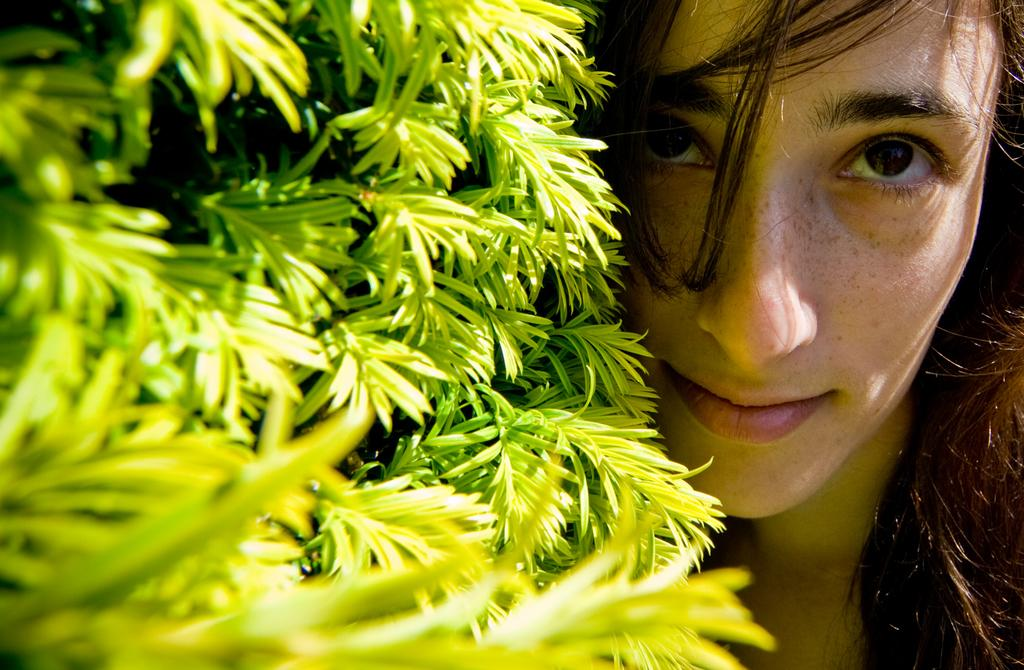Who is present in the picture? There is a woman in the picture. What can be seen on the left side of the picture? There are green leaves on the left side of the picture. What type of meat is being cooked on the right side of the picture? There is no meat or cooking activity present in the image; it only features a woman and green leaves. 